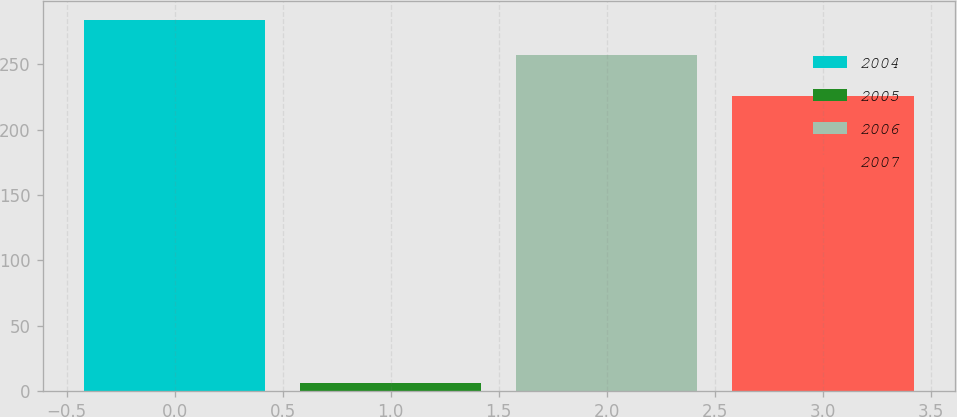<chart> <loc_0><loc_0><loc_500><loc_500><bar_chart><fcel>2004<fcel>2005<fcel>2006<fcel>2007<nl><fcel>283.9<fcel>6<fcel>257<fcel>226<nl></chart> 